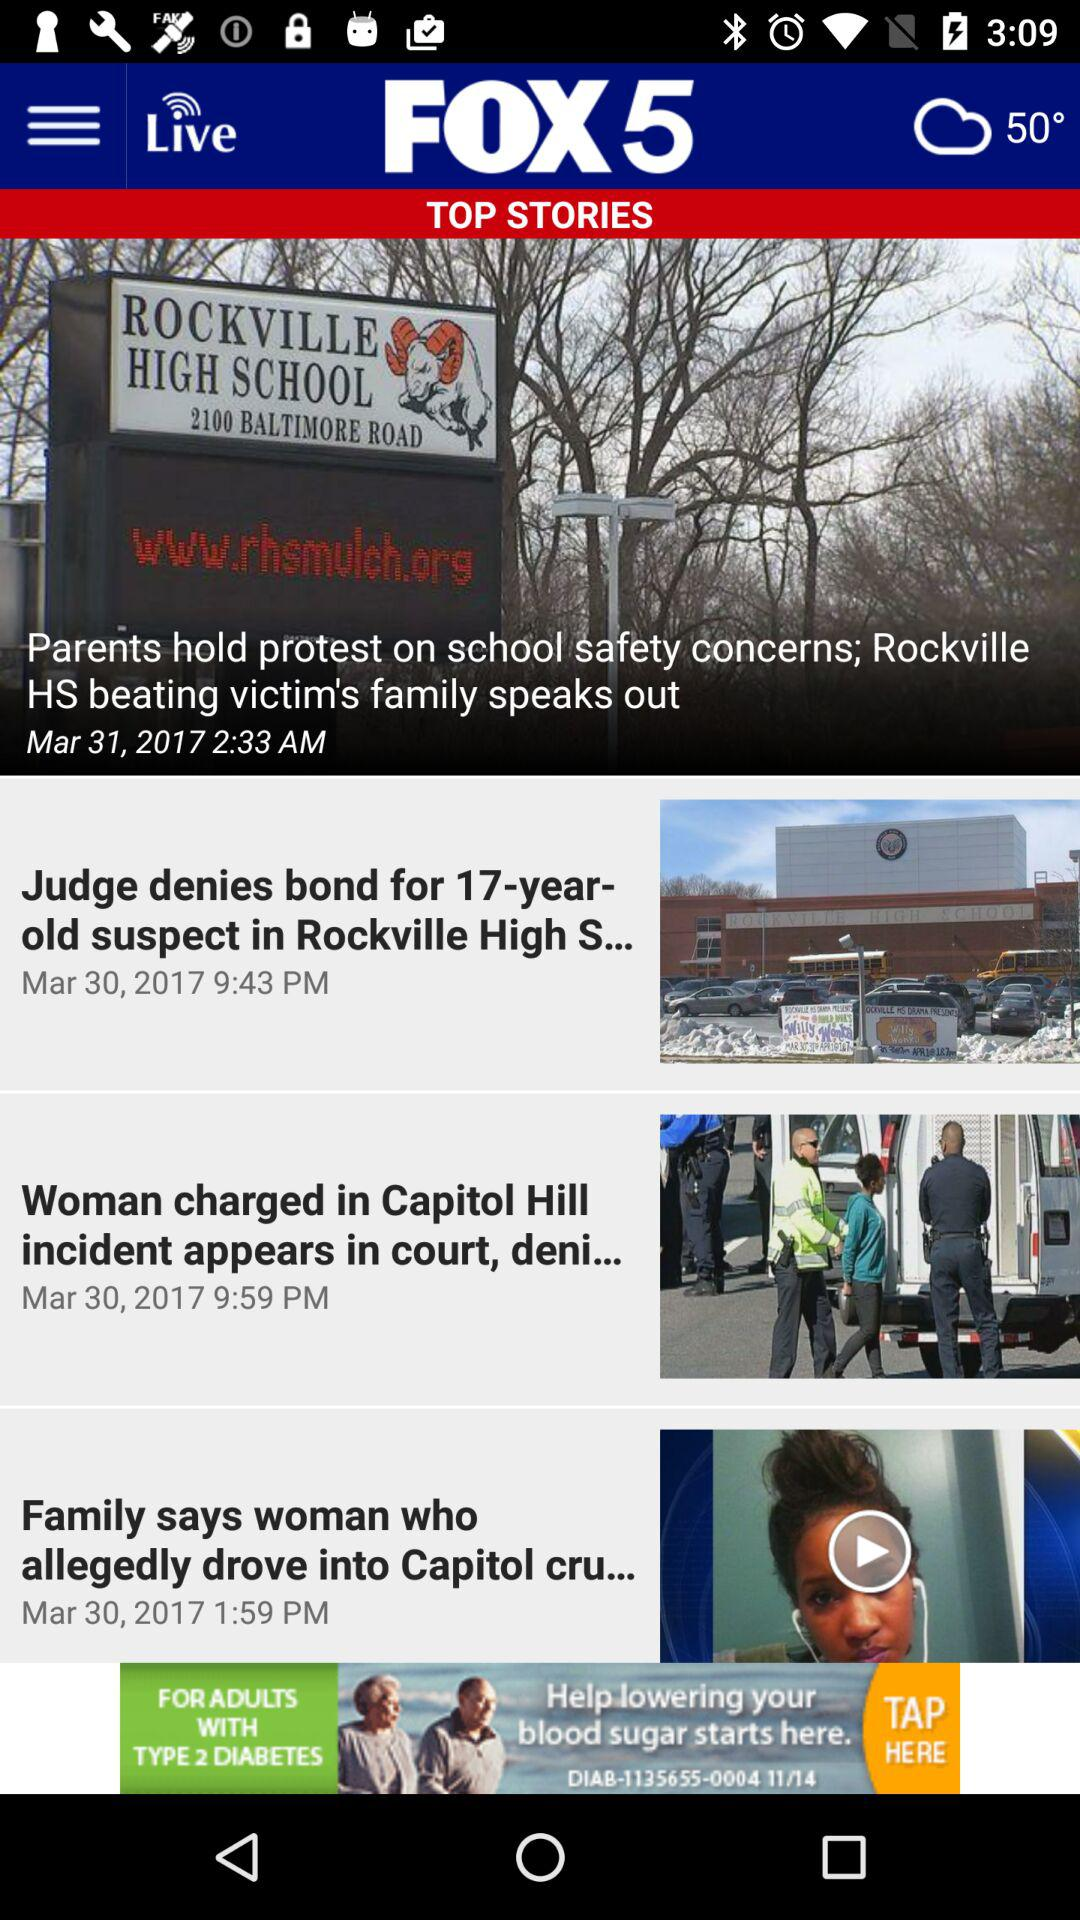Which stories were posted on March 31, 2017? The story posted on March 31, 2017 is "Parents hold protest on school safety concerns; Rockville HS beating victim's family speaks out". 